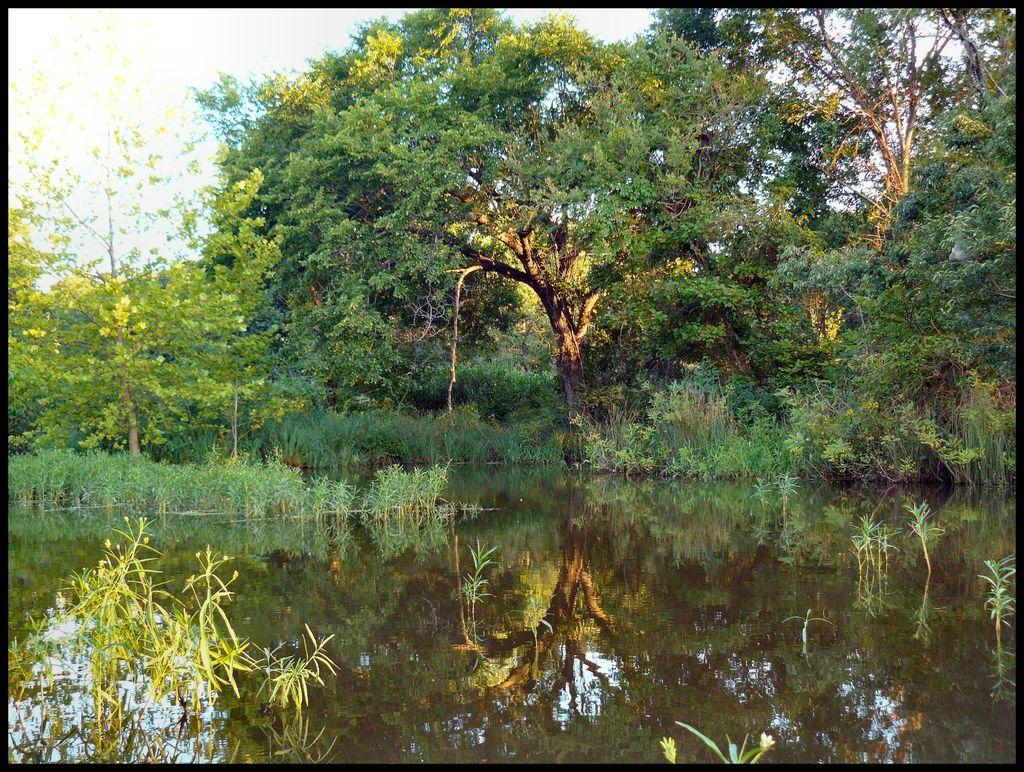What is the primary element in the image? The image consists of water. What can be seen in the background of the image? There are many trees and plants in the background. Where might this image have been taken? The image appears to be taken near a pond. What is visible at the top of the image? The sky is visible at the top of the image. What type of industry can be seen in the image? There is no industry present in the image; it consists of water, trees, plants, and the sky. How many houses are visible in the image? There are no houses visible in the image; it primarily features water, trees, plants, and the sky. 